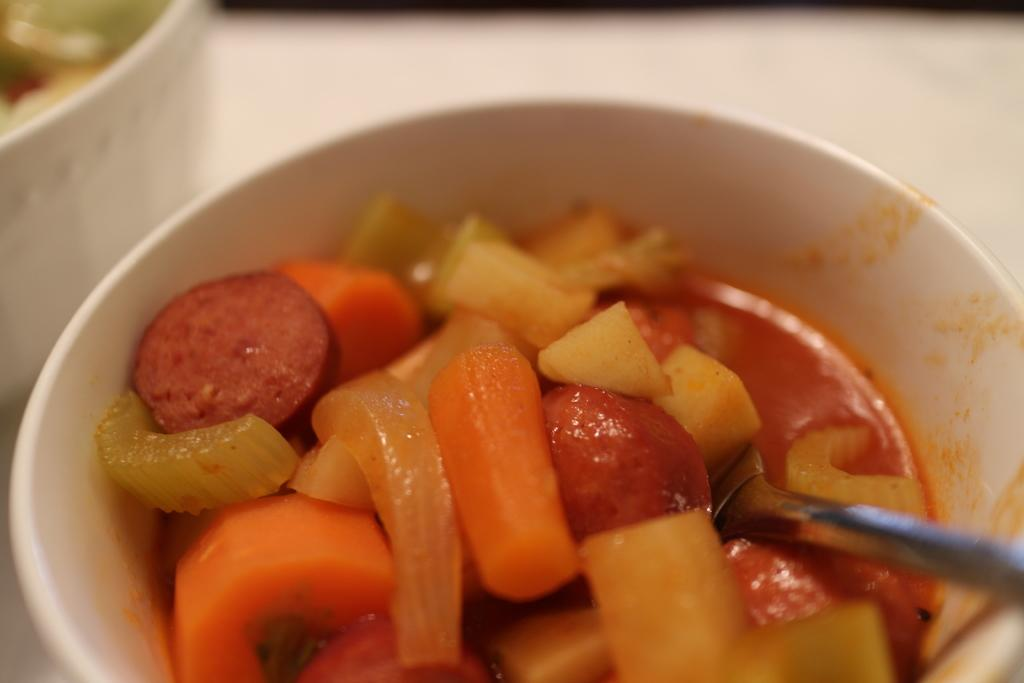What is the main subject of the image? There is a food item in the image. What utensil is present in the image? There is a spoon in the bowl in the image. What is the object on a platform in the image? The facts do not specify the object on the platform, so we cannot answer this question definitively. What is the name of the kittens playing with the spoon in the image? There are no kittens present in the image, and the spoon is in the bowl with the food item. 